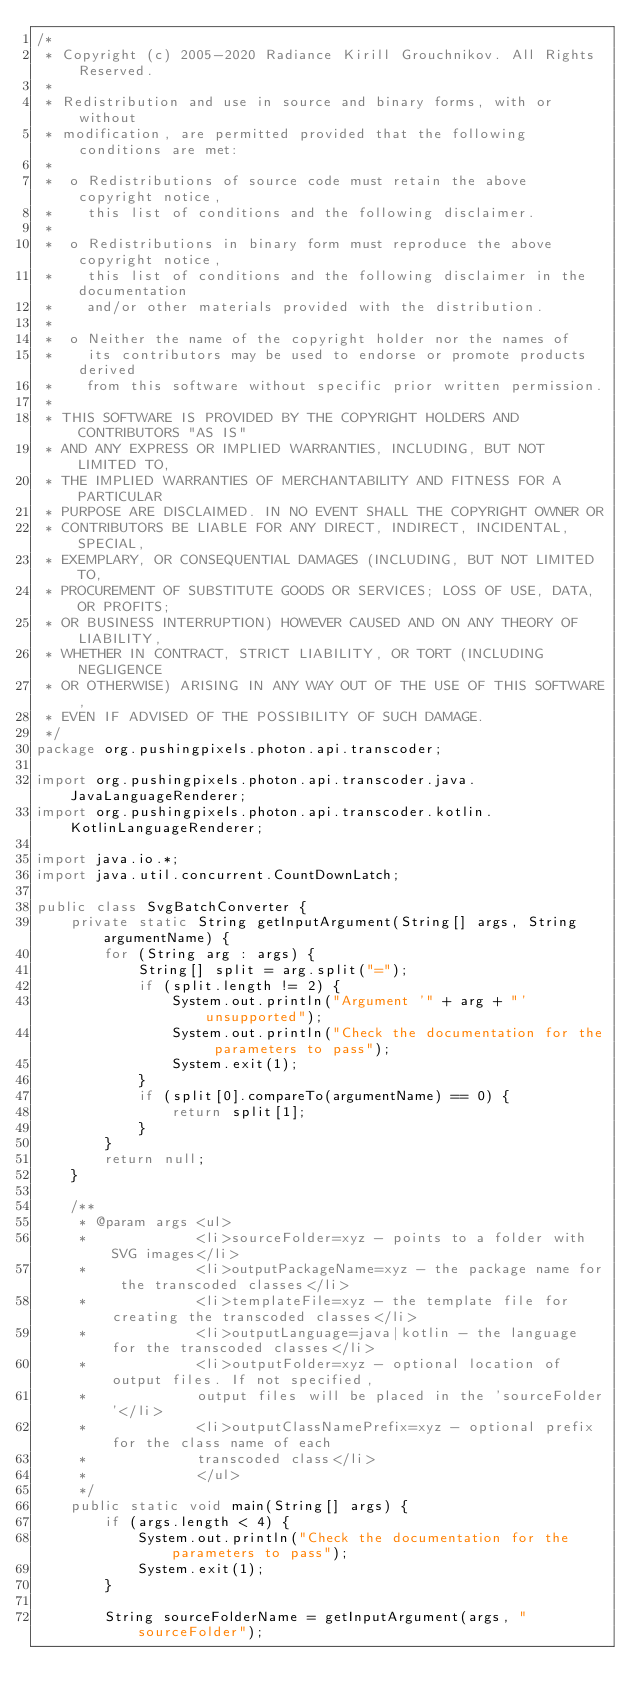Convert code to text. <code><loc_0><loc_0><loc_500><loc_500><_Java_>/*
 * Copyright (c) 2005-2020 Radiance Kirill Grouchnikov. All Rights Reserved.
 *
 * Redistribution and use in source and binary forms, with or without
 * modification, are permitted provided that the following conditions are met:
 *
 *  o Redistributions of source code must retain the above copyright notice,
 *    this list of conditions and the following disclaimer.
 *
 *  o Redistributions in binary form must reproduce the above copyright notice,
 *    this list of conditions and the following disclaimer in the documentation
 *    and/or other materials provided with the distribution.
 *
 *  o Neither the name of the copyright holder nor the names of
 *    its contributors may be used to endorse or promote products derived
 *    from this software without specific prior written permission.
 *
 * THIS SOFTWARE IS PROVIDED BY THE COPYRIGHT HOLDERS AND CONTRIBUTORS "AS IS"
 * AND ANY EXPRESS OR IMPLIED WARRANTIES, INCLUDING, BUT NOT LIMITED TO,
 * THE IMPLIED WARRANTIES OF MERCHANTABILITY AND FITNESS FOR A PARTICULAR
 * PURPOSE ARE DISCLAIMED. IN NO EVENT SHALL THE COPYRIGHT OWNER OR
 * CONTRIBUTORS BE LIABLE FOR ANY DIRECT, INDIRECT, INCIDENTAL, SPECIAL,
 * EXEMPLARY, OR CONSEQUENTIAL DAMAGES (INCLUDING, BUT NOT LIMITED TO,
 * PROCUREMENT OF SUBSTITUTE GOODS OR SERVICES; LOSS OF USE, DATA, OR PROFITS;
 * OR BUSINESS INTERRUPTION) HOWEVER CAUSED AND ON ANY THEORY OF LIABILITY,
 * WHETHER IN CONTRACT, STRICT LIABILITY, OR TORT (INCLUDING NEGLIGENCE
 * OR OTHERWISE) ARISING IN ANY WAY OUT OF THE USE OF THIS SOFTWARE,
 * EVEN IF ADVISED OF THE POSSIBILITY OF SUCH DAMAGE.
 */
package org.pushingpixels.photon.api.transcoder;

import org.pushingpixels.photon.api.transcoder.java.JavaLanguageRenderer;
import org.pushingpixels.photon.api.transcoder.kotlin.KotlinLanguageRenderer;

import java.io.*;
import java.util.concurrent.CountDownLatch;

public class SvgBatchConverter {
    private static String getInputArgument(String[] args, String argumentName) {
        for (String arg : args) {
            String[] split = arg.split("=");
            if (split.length != 2) {
                System.out.println("Argument '" + arg + "' unsupported");
                System.out.println("Check the documentation for the parameters to pass");
                System.exit(1);
            }
            if (split[0].compareTo(argumentName) == 0) {
                return split[1];
            }
        }
        return null;
    }

    /**
     * @param args <ul>
     *             <li>sourceFolder=xyz - points to a folder with SVG images</li>
     *             <li>outputPackageName=xyz - the package name for the transcoded classes</li>
     *             <li>templateFile=xyz - the template file for creating the transcoded classes</li>
     *             <li>outputLanguage=java|kotlin - the language for the transcoded classes</li>
     *             <li>outputFolder=xyz - optional location of output files. If not specified,
     *             output files will be placed in the 'sourceFolder'</li>
     *             <li>outputClassNamePrefix=xyz - optional prefix for the class name of each
     *             transcoded class</li>
     *             </ul>
     */
    public static void main(String[] args) {
        if (args.length < 4) {
            System.out.println("Check the documentation for the parameters to pass");
            System.exit(1);
        }

        String sourceFolderName = getInputArgument(args, "sourceFolder");</code> 